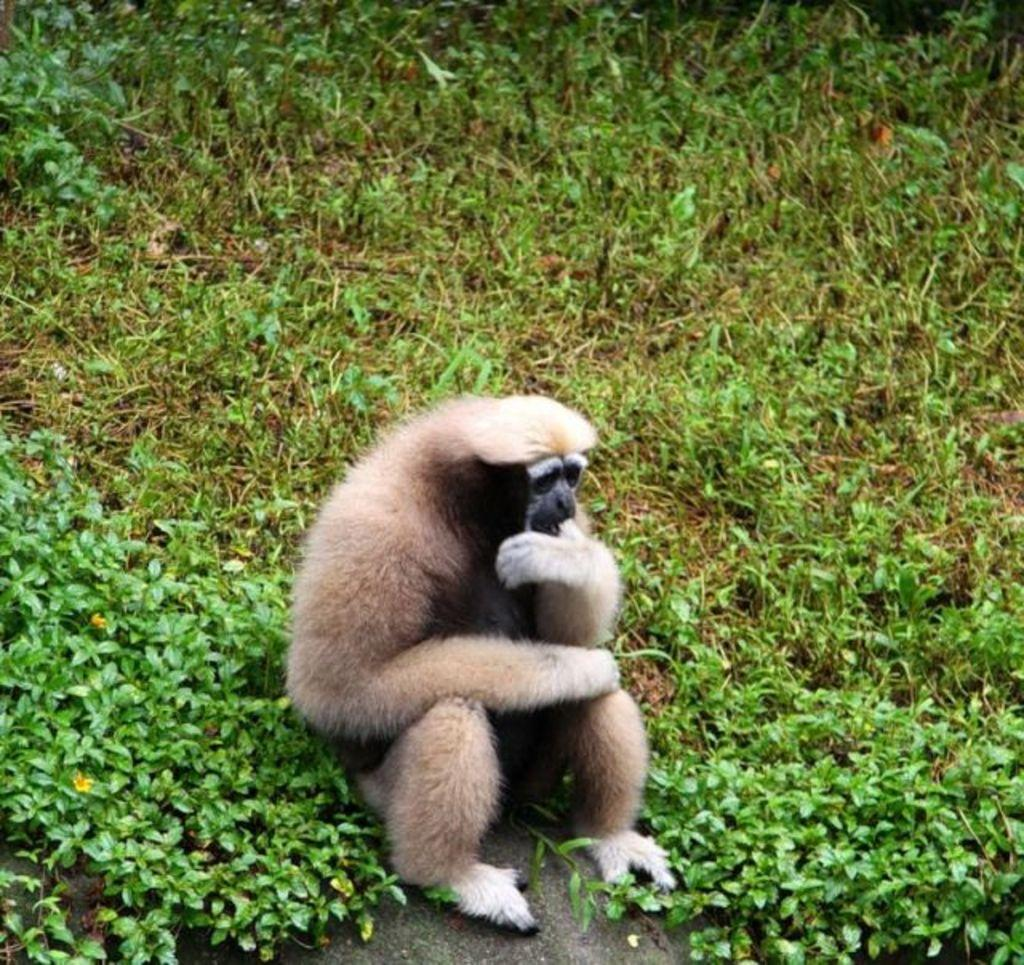What animal is present in the image? There is a monkey in the image. Where is the monkey located? The monkey is sitting on a grassland. Who is the owner of the deer in the image? A: There is no deer present in the image, only a monkey. What type of pail can be seen in the image? There is no pail present in the image; it only features a monkey sitting on a grassland. 